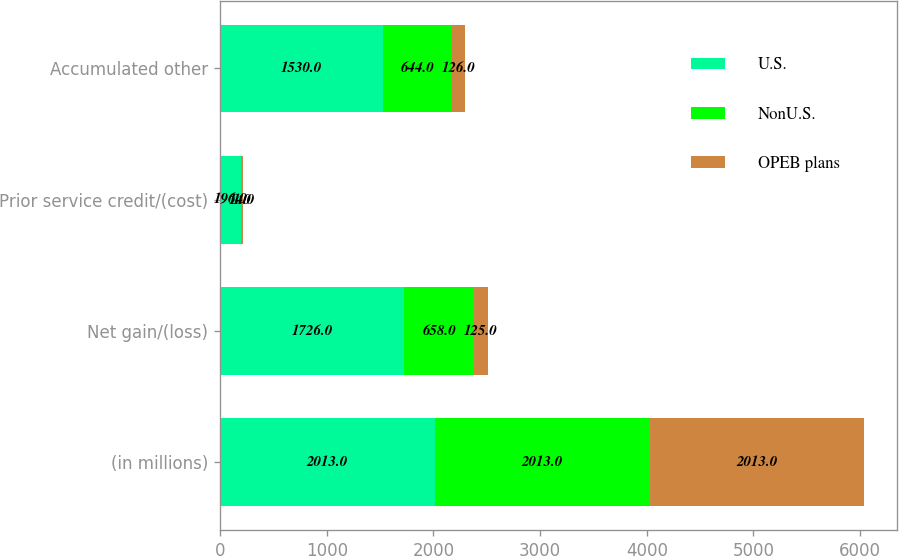<chart> <loc_0><loc_0><loc_500><loc_500><stacked_bar_chart><ecel><fcel>(in millions)<fcel>Net gain/(loss)<fcel>Prior service credit/(cost)<fcel>Accumulated other<nl><fcel>U.S.<fcel>2013<fcel>1726<fcel>196<fcel>1530<nl><fcel>NonU.S.<fcel>2013<fcel>658<fcel>14<fcel>644<nl><fcel>OPEB plans<fcel>2013<fcel>125<fcel>1<fcel>126<nl></chart> 